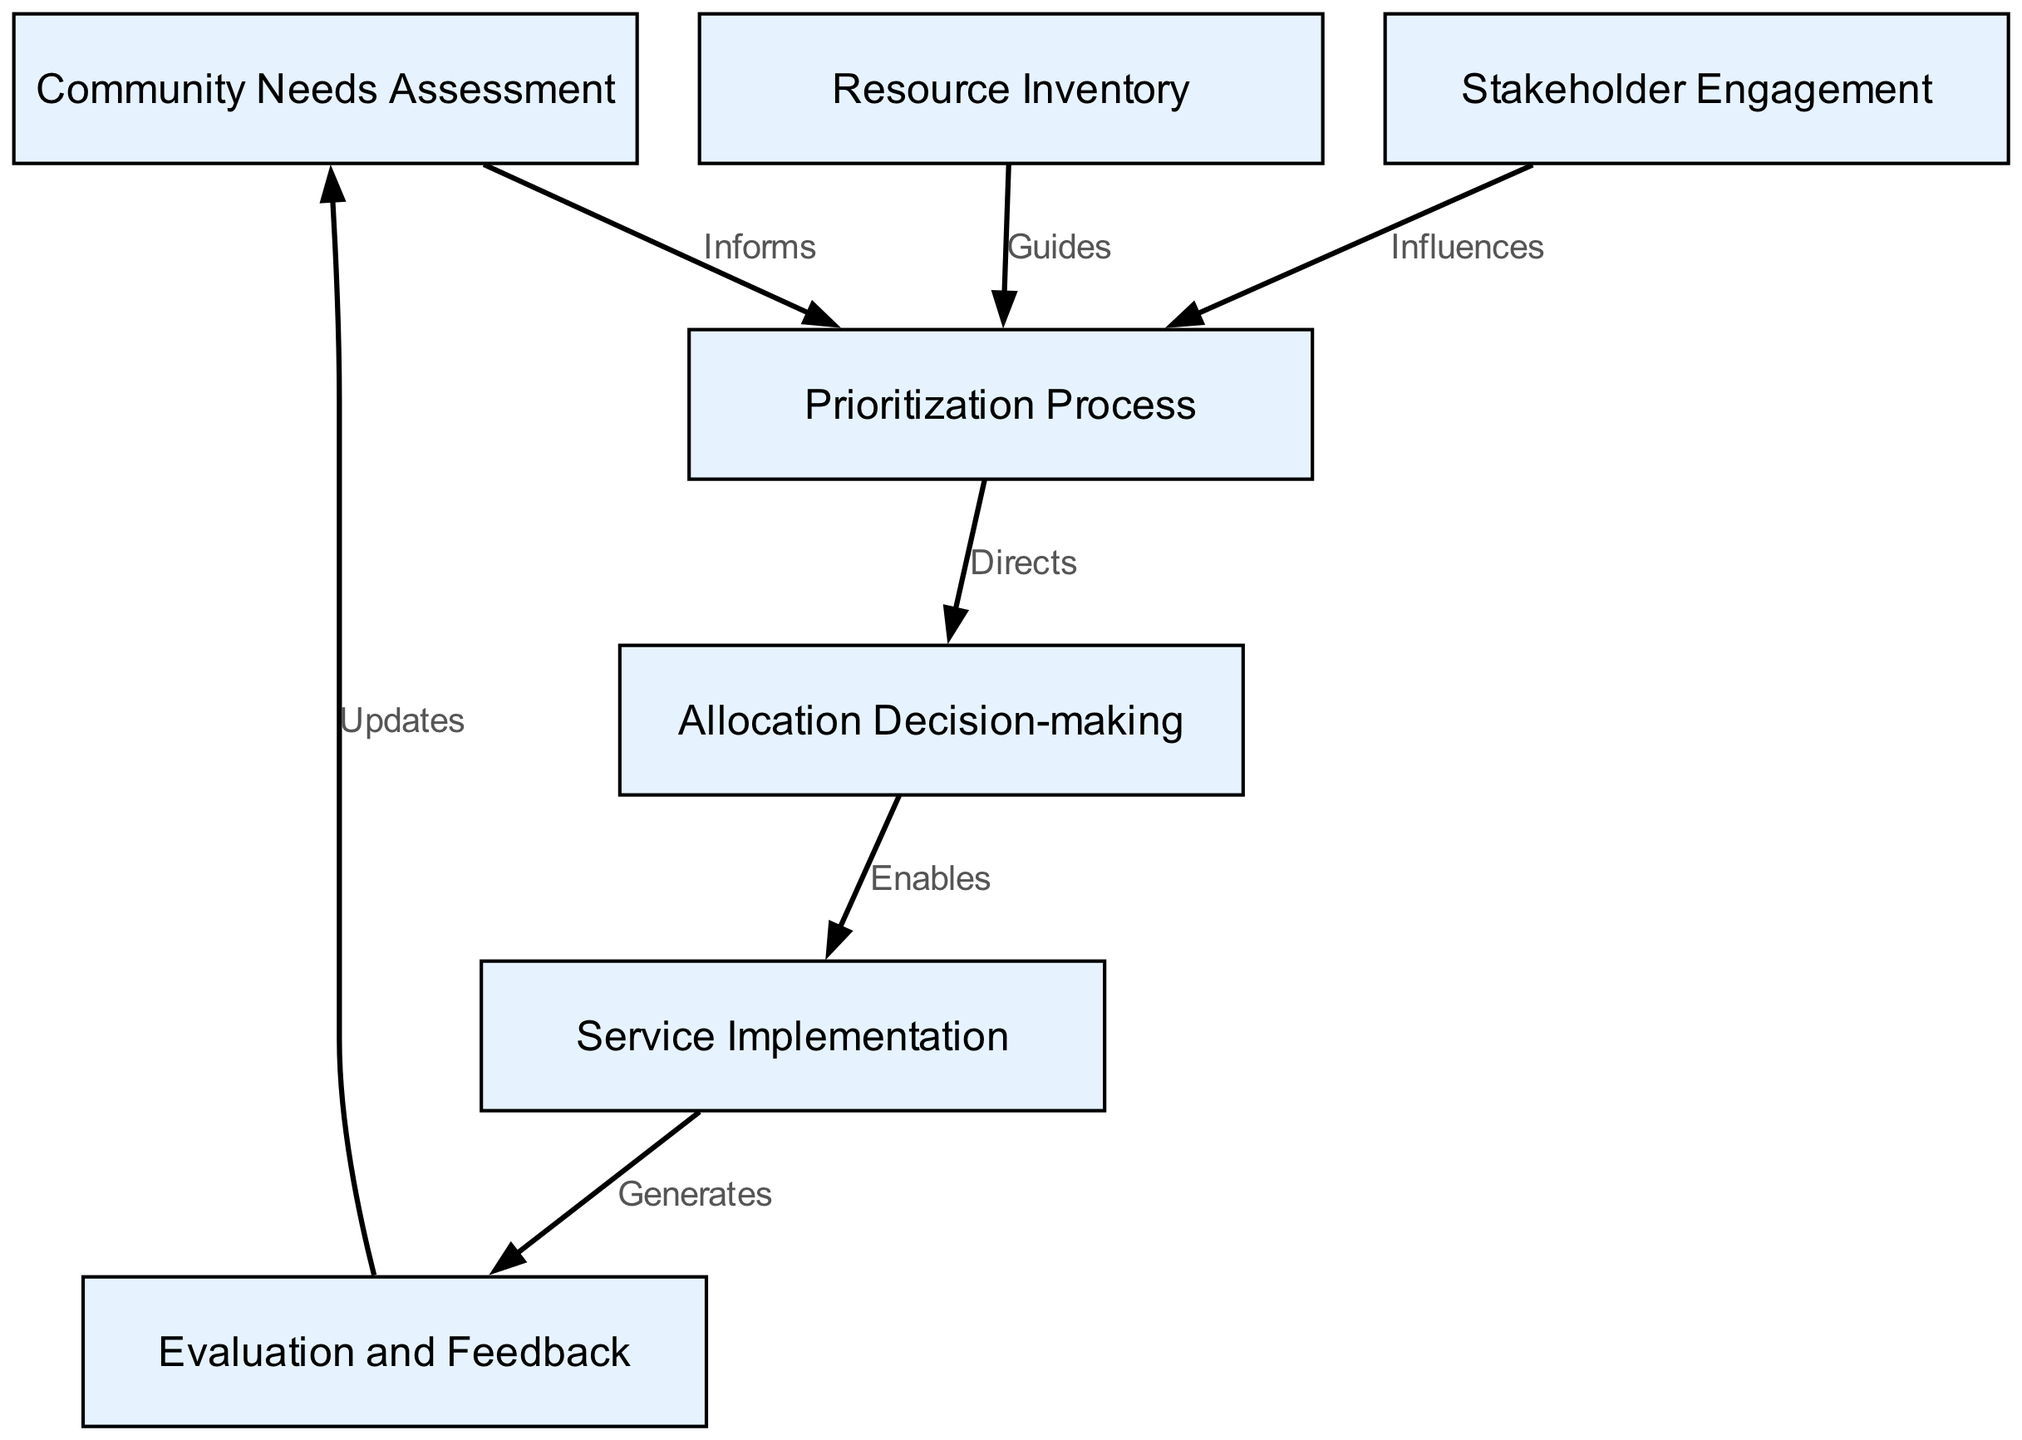What is the first node in the diagram? The first node is labeled "Community Needs Assessment," which is positioned at the top of the diagram.
Answer: Community Needs Assessment How many nodes are present in the diagram? By counting each entry in the nodes list, we find that there are a total of seven nodes represented in the diagram.
Answer: 7 Which node directly influences the Prioritization Process? Analyzing the edges, we see that "Stakeholder Engagement" has an edge labeled "Influences" that leads into the Prioritization Process.
Answer: Stakeholder Engagement What is the relationship between the Resource Inventory and the Prioritization Process? The edge connecting "Resource Inventory" to "Prioritization Process" is labeled "Guides," indicating that the Resource Inventory provides guidance for the Prioritization Process.
Answer: Guides What node generates feedback? Following the arrows from "Service Implementation," we find that it connects to "Evaluation and Feedback," which signifies that this node generates feedback after services are implemented.
Answer: Evaluation and Feedback What does the Allocation Decision-making node enable? From the diagram, there is a direct edge from "Allocation Decision-making" to "Service Implementation," indicating that it enables service implementation.
Answer: Service Implementation How does the process get updated? The "Evaluation and Feedback" node has an edge labeled "Updates" that connects back to the "Community Needs Assessment," indicating how the process is updated.
Answer: Community Needs Assessment What is the primary purpose of the Community Needs Assessment? The Community Needs Assessment serves as the initial step to inform the entire framework and consequently supports the prioritization process.
Answer: Informs What does the Evaluation and Feedback node connect to next? Following the directed edge from "Evaluation and Feedback," it connects back to "Community Needs Assessment," completing the feedback loop to update the community needs.
Answer: Community Needs Assessment 